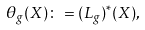<formula> <loc_0><loc_0><loc_500><loc_500>\theta _ { g } ( X ) \colon = ( L _ { g } ) ^ { * } ( X ) ,</formula> 